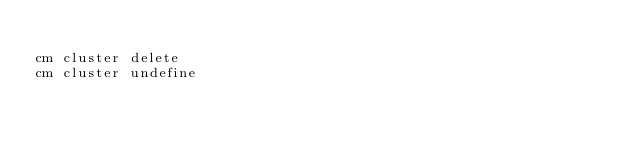Convert code to text. <code><loc_0><loc_0><loc_500><loc_500><_Bash_>
cm cluster delete
cm cluster undefine

</code> 